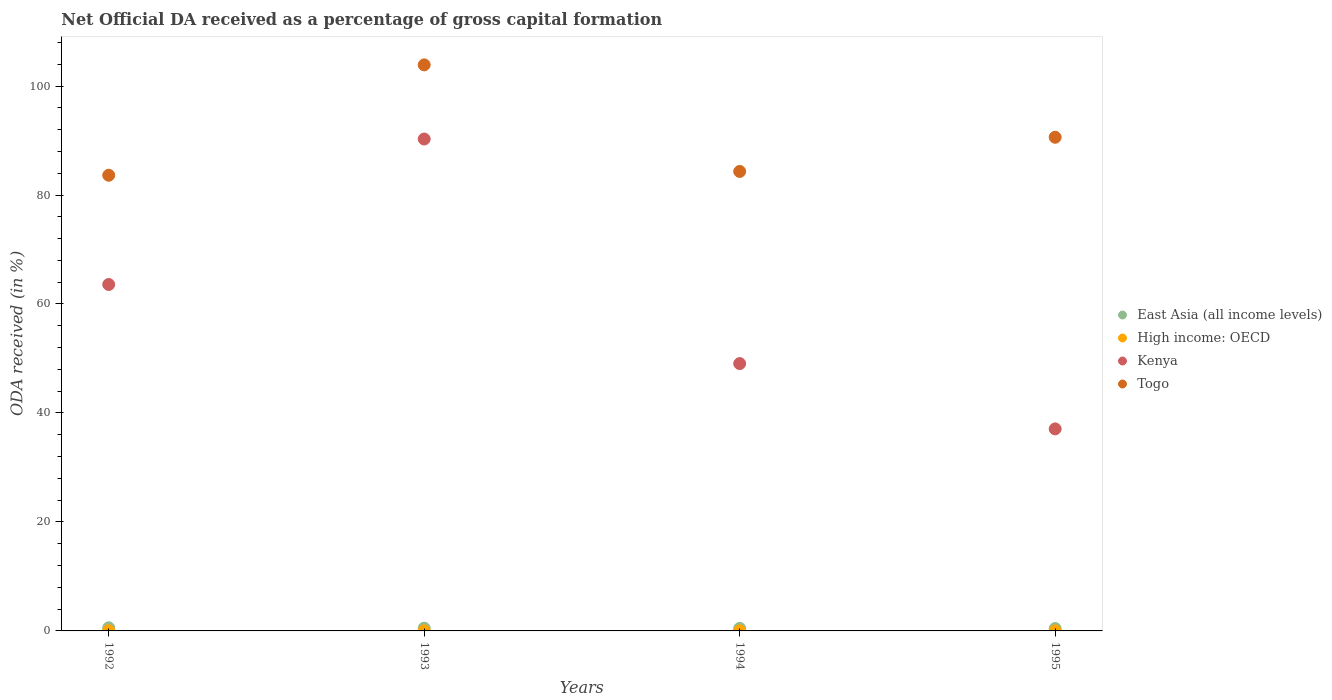How many different coloured dotlines are there?
Your response must be concise. 4. What is the net ODA received in Togo in 1993?
Ensure brevity in your answer.  103.88. Across all years, what is the maximum net ODA received in Togo?
Ensure brevity in your answer.  103.88. Across all years, what is the minimum net ODA received in Togo?
Provide a short and direct response. 83.62. In which year was the net ODA received in East Asia (all income levels) minimum?
Ensure brevity in your answer.  1995. What is the total net ODA received in East Asia (all income levels) in the graph?
Offer a terse response. 1.99. What is the difference between the net ODA received in Togo in 1992 and that in 1995?
Keep it short and to the point. -6.97. What is the difference between the net ODA received in Togo in 1993 and the net ODA received in East Asia (all income levels) in 1995?
Your answer should be compact. 103.45. What is the average net ODA received in Kenya per year?
Your answer should be compact. 60. In the year 1992, what is the difference between the net ODA received in Togo and net ODA received in High income: OECD?
Your answer should be very brief. 83.58. In how many years, is the net ODA received in Togo greater than 56 %?
Provide a short and direct response. 4. What is the ratio of the net ODA received in Kenya in 1992 to that in 1995?
Keep it short and to the point. 1.71. Is the net ODA received in Kenya in 1994 less than that in 1995?
Your response must be concise. No. What is the difference between the highest and the second highest net ODA received in High income: OECD?
Give a very brief answer. 0.02. What is the difference between the highest and the lowest net ODA received in East Asia (all income levels)?
Offer a terse response. 0.15. In how many years, is the net ODA received in Kenya greater than the average net ODA received in Kenya taken over all years?
Make the answer very short. 2. Does the net ODA received in Kenya monotonically increase over the years?
Offer a very short reply. No. Is the net ODA received in Togo strictly greater than the net ODA received in East Asia (all income levels) over the years?
Offer a very short reply. Yes. Is the net ODA received in East Asia (all income levels) strictly less than the net ODA received in Kenya over the years?
Ensure brevity in your answer.  Yes. How many dotlines are there?
Give a very brief answer. 4. Does the graph contain any zero values?
Give a very brief answer. No. How many legend labels are there?
Keep it short and to the point. 4. What is the title of the graph?
Make the answer very short. Net Official DA received as a percentage of gross capital formation. What is the label or title of the Y-axis?
Offer a very short reply. ODA received (in %). What is the ODA received (in %) of East Asia (all income levels) in 1992?
Offer a very short reply. 0.58. What is the ODA received (in %) of High income: OECD in 1992?
Your answer should be very brief. 0.05. What is the ODA received (in %) of Kenya in 1992?
Give a very brief answer. 63.58. What is the ODA received (in %) of Togo in 1992?
Provide a succinct answer. 83.62. What is the ODA received (in %) in East Asia (all income levels) in 1993?
Offer a very short reply. 0.5. What is the ODA received (in %) of High income: OECD in 1993?
Your answer should be very brief. 0.03. What is the ODA received (in %) in Kenya in 1993?
Your answer should be very brief. 90.27. What is the ODA received (in %) in Togo in 1993?
Keep it short and to the point. 103.88. What is the ODA received (in %) in East Asia (all income levels) in 1994?
Give a very brief answer. 0.47. What is the ODA received (in %) of High income: OECD in 1994?
Your response must be concise. 0.03. What is the ODA received (in %) in Kenya in 1994?
Offer a very short reply. 49.06. What is the ODA received (in %) in Togo in 1994?
Your response must be concise. 84.32. What is the ODA received (in %) of East Asia (all income levels) in 1995?
Your answer should be compact. 0.43. What is the ODA received (in %) in High income: OECD in 1995?
Make the answer very short. 0.01. What is the ODA received (in %) in Kenya in 1995?
Offer a terse response. 37.08. What is the ODA received (in %) of Togo in 1995?
Make the answer very short. 90.6. Across all years, what is the maximum ODA received (in %) of East Asia (all income levels)?
Keep it short and to the point. 0.58. Across all years, what is the maximum ODA received (in %) of High income: OECD?
Your response must be concise. 0.05. Across all years, what is the maximum ODA received (in %) in Kenya?
Offer a terse response. 90.27. Across all years, what is the maximum ODA received (in %) in Togo?
Keep it short and to the point. 103.88. Across all years, what is the minimum ODA received (in %) in East Asia (all income levels)?
Offer a very short reply. 0.43. Across all years, what is the minimum ODA received (in %) of High income: OECD?
Ensure brevity in your answer.  0.01. Across all years, what is the minimum ODA received (in %) in Kenya?
Your answer should be very brief. 37.08. Across all years, what is the minimum ODA received (in %) of Togo?
Give a very brief answer. 83.62. What is the total ODA received (in %) of East Asia (all income levels) in the graph?
Offer a terse response. 1.99. What is the total ODA received (in %) of High income: OECD in the graph?
Your response must be concise. 0.11. What is the total ODA received (in %) of Kenya in the graph?
Your response must be concise. 239.99. What is the total ODA received (in %) in Togo in the graph?
Make the answer very short. 362.43. What is the difference between the ODA received (in %) of East Asia (all income levels) in 1992 and that in 1993?
Provide a succinct answer. 0.08. What is the difference between the ODA received (in %) of High income: OECD in 1992 and that in 1993?
Your response must be concise. 0.02. What is the difference between the ODA received (in %) of Kenya in 1992 and that in 1993?
Ensure brevity in your answer.  -26.69. What is the difference between the ODA received (in %) of Togo in 1992 and that in 1993?
Keep it short and to the point. -20.26. What is the difference between the ODA received (in %) of East Asia (all income levels) in 1992 and that in 1994?
Offer a terse response. 0.11. What is the difference between the ODA received (in %) in High income: OECD in 1992 and that in 1994?
Your response must be concise. 0.02. What is the difference between the ODA received (in %) in Kenya in 1992 and that in 1994?
Provide a short and direct response. 14.52. What is the difference between the ODA received (in %) in Togo in 1992 and that in 1994?
Ensure brevity in your answer.  -0.7. What is the difference between the ODA received (in %) in East Asia (all income levels) in 1992 and that in 1995?
Give a very brief answer. 0.15. What is the difference between the ODA received (in %) of High income: OECD in 1992 and that in 1995?
Your response must be concise. 0.04. What is the difference between the ODA received (in %) in Kenya in 1992 and that in 1995?
Keep it short and to the point. 26.5. What is the difference between the ODA received (in %) of Togo in 1992 and that in 1995?
Your answer should be compact. -6.97. What is the difference between the ODA received (in %) in East Asia (all income levels) in 1993 and that in 1994?
Your answer should be compact. 0.04. What is the difference between the ODA received (in %) of High income: OECD in 1993 and that in 1994?
Keep it short and to the point. 0. What is the difference between the ODA received (in %) in Kenya in 1993 and that in 1994?
Make the answer very short. 41.21. What is the difference between the ODA received (in %) of Togo in 1993 and that in 1994?
Keep it short and to the point. 19.56. What is the difference between the ODA received (in %) in East Asia (all income levels) in 1993 and that in 1995?
Ensure brevity in your answer.  0.07. What is the difference between the ODA received (in %) in High income: OECD in 1993 and that in 1995?
Your response must be concise. 0.02. What is the difference between the ODA received (in %) in Kenya in 1993 and that in 1995?
Keep it short and to the point. 53.2. What is the difference between the ODA received (in %) in Togo in 1993 and that in 1995?
Offer a terse response. 13.28. What is the difference between the ODA received (in %) of East Asia (all income levels) in 1994 and that in 1995?
Ensure brevity in your answer.  0.03. What is the difference between the ODA received (in %) in High income: OECD in 1994 and that in 1995?
Offer a terse response. 0.01. What is the difference between the ODA received (in %) in Kenya in 1994 and that in 1995?
Keep it short and to the point. 11.99. What is the difference between the ODA received (in %) in Togo in 1994 and that in 1995?
Your answer should be very brief. -6.27. What is the difference between the ODA received (in %) of East Asia (all income levels) in 1992 and the ODA received (in %) of High income: OECD in 1993?
Provide a succinct answer. 0.55. What is the difference between the ODA received (in %) in East Asia (all income levels) in 1992 and the ODA received (in %) in Kenya in 1993?
Your response must be concise. -89.69. What is the difference between the ODA received (in %) of East Asia (all income levels) in 1992 and the ODA received (in %) of Togo in 1993?
Give a very brief answer. -103.3. What is the difference between the ODA received (in %) of High income: OECD in 1992 and the ODA received (in %) of Kenya in 1993?
Make the answer very short. -90.23. What is the difference between the ODA received (in %) of High income: OECD in 1992 and the ODA received (in %) of Togo in 1993?
Make the answer very short. -103.84. What is the difference between the ODA received (in %) in Kenya in 1992 and the ODA received (in %) in Togo in 1993?
Keep it short and to the point. -40.3. What is the difference between the ODA received (in %) in East Asia (all income levels) in 1992 and the ODA received (in %) in High income: OECD in 1994?
Your answer should be very brief. 0.55. What is the difference between the ODA received (in %) in East Asia (all income levels) in 1992 and the ODA received (in %) in Kenya in 1994?
Give a very brief answer. -48.48. What is the difference between the ODA received (in %) of East Asia (all income levels) in 1992 and the ODA received (in %) of Togo in 1994?
Provide a short and direct response. -83.74. What is the difference between the ODA received (in %) of High income: OECD in 1992 and the ODA received (in %) of Kenya in 1994?
Give a very brief answer. -49.02. What is the difference between the ODA received (in %) in High income: OECD in 1992 and the ODA received (in %) in Togo in 1994?
Offer a terse response. -84.28. What is the difference between the ODA received (in %) of Kenya in 1992 and the ODA received (in %) of Togo in 1994?
Give a very brief answer. -20.75. What is the difference between the ODA received (in %) of East Asia (all income levels) in 1992 and the ODA received (in %) of High income: OECD in 1995?
Your answer should be very brief. 0.57. What is the difference between the ODA received (in %) in East Asia (all income levels) in 1992 and the ODA received (in %) in Kenya in 1995?
Keep it short and to the point. -36.5. What is the difference between the ODA received (in %) in East Asia (all income levels) in 1992 and the ODA received (in %) in Togo in 1995?
Your answer should be very brief. -90.02. What is the difference between the ODA received (in %) in High income: OECD in 1992 and the ODA received (in %) in Kenya in 1995?
Provide a short and direct response. -37.03. What is the difference between the ODA received (in %) of High income: OECD in 1992 and the ODA received (in %) of Togo in 1995?
Your response must be concise. -90.55. What is the difference between the ODA received (in %) of Kenya in 1992 and the ODA received (in %) of Togo in 1995?
Your answer should be very brief. -27.02. What is the difference between the ODA received (in %) in East Asia (all income levels) in 1993 and the ODA received (in %) in High income: OECD in 1994?
Your answer should be very brief. 0.48. What is the difference between the ODA received (in %) in East Asia (all income levels) in 1993 and the ODA received (in %) in Kenya in 1994?
Offer a very short reply. -48.56. What is the difference between the ODA received (in %) in East Asia (all income levels) in 1993 and the ODA received (in %) in Togo in 1994?
Give a very brief answer. -83.82. What is the difference between the ODA received (in %) in High income: OECD in 1993 and the ODA received (in %) in Kenya in 1994?
Your answer should be very brief. -49.03. What is the difference between the ODA received (in %) in High income: OECD in 1993 and the ODA received (in %) in Togo in 1994?
Provide a succinct answer. -84.3. What is the difference between the ODA received (in %) of Kenya in 1993 and the ODA received (in %) of Togo in 1994?
Give a very brief answer. 5.95. What is the difference between the ODA received (in %) of East Asia (all income levels) in 1993 and the ODA received (in %) of High income: OECD in 1995?
Your answer should be compact. 0.49. What is the difference between the ODA received (in %) in East Asia (all income levels) in 1993 and the ODA received (in %) in Kenya in 1995?
Provide a succinct answer. -36.57. What is the difference between the ODA received (in %) of East Asia (all income levels) in 1993 and the ODA received (in %) of Togo in 1995?
Make the answer very short. -90.09. What is the difference between the ODA received (in %) of High income: OECD in 1993 and the ODA received (in %) of Kenya in 1995?
Your response must be concise. -37.05. What is the difference between the ODA received (in %) of High income: OECD in 1993 and the ODA received (in %) of Togo in 1995?
Provide a succinct answer. -90.57. What is the difference between the ODA received (in %) in Kenya in 1993 and the ODA received (in %) in Togo in 1995?
Your answer should be very brief. -0.32. What is the difference between the ODA received (in %) of East Asia (all income levels) in 1994 and the ODA received (in %) of High income: OECD in 1995?
Give a very brief answer. 0.46. What is the difference between the ODA received (in %) in East Asia (all income levels) in 1994 and the ODA received (in %) in Kenya in 1995?
Your answer should be compact. -36.61. What is the difference between the ODA received (in %) of East Asia (all income levels) in 1994 and the ODA received (in %) of Togo in 1995?
Give a very brief answer. -90.13. What is the difference between the ODA received (in %) in High income: OECD in 1994 and the ODA received (in %) in Kenya in 1995?
Your answer should be compact. -37.05. What is the difference between the ODA received (in %) in High income: OECD in 1994 and the ODA received (in %) in Togo in 1995?
Provide a succinct answer. -90.57. What is the difference between the ODA received (in %) of Kenya in 1994 and the ODA received (in %) of Togo in 1995?
Your answer should be compact. -41.53. What is the average ODA received (in %) of East Asia (all income levels) per year?
Keep it short and to the point. 0.5. What is the average ODA received (in %) in High income: OECD per year?
Your response must be concise. 0.03. What is the average ODA received (in %) of Kenya per year?
Provide a succinct answer. 60. What is the average ODA received (in %) of Togo per year?
Offer a very short reply. 90.61. In the year 1992, what is the difference between the ODA received (in %) of East Asia (all income levels) and ODA received (in %) of High income: OECD?
Ensure brevity in your answer.  0.53. In the year 1992, what is the difference between the ODA received (in %) in East Asia (all income levels) and ODA received (in %) in Kenya?
Provide a succinct answer. -63. In the year 1992, what is the difference between the ODA received (in %) in East Asia (all income levels) and ODA received (in %) in Togo?
Provide a short and direct response. -83.04. In the year 1992, what is the difference between the ODA received (in %) in High income: OECD and ODA received (in %) in Kenya?
Your answer should be compact. -63.53. In the year 1992, what is the difference between the ODA received (in %) in High income: OECD and ODA received (in %) in Togo?
Your answer should be compact. -83.58. In the year 1992, what is the difference between the ODA received (in %) in Kenya and ODA received (in %) in Togo?
Keep it short and to the point. -20.05. In the year 1993, what is the difference between the ODA received (in %) in East Asia (all income levels) and ODA received (in %) in High income: OECD?
Your response must be concise. 0.47. In the year 1993, what is the difference between the ODA received (in %) of East Asia (all income levels) and ODA received (in %) of Kenya?
Provide a short and direct response. -89.77. In the year 1993, what is the difference between the ODA received (in %) in East Asia (all income levels) and ODA received (in %) in Togo?
Make the answer very short. -103.38. In the year 1993, what is the difference between the ODA received (in %) of High income: OECD and ODA received (in %) of Kenya?
Your response must be concise. -90.24. In the year 1993, what is the difference between the ODA received (in %) of High income: OECD and ODA received (in %) of Togo?
Keep it short and to the point. -103.85. In the year 1993, what is the difference between the ODA received (in %) of Kenya and ODA received (in %) of Togo?
Give a very brief answer. -13.61. In the year 1994, what is the difference between the ODA received (in %) of East Asia (all income levels) and ODA received (in %) of High income: OECD?
Provide a short and direct response. 0.44. In the year 1994, what is the difference between the ODA received (in %) of East Asia (all income levels) and ODA received (in %) of Kenya?
Give a very brief answer. -48.6. In the year 1994, what is the difference between the ODA received (in %) of East Asia (all income levels) and ODA received (in %) of Togo?
Ensure brevity in your answer.  -83.86. In the year 1994, what is the difference between the ODA received (in %) in High income: OECD and ODA received (in %) in Kenya?
Your answer should be very brief. -49.04. In the year 1994, what is the difference between the ODA received (in %) of High income: OECD and ODA received (in %) of Togo?
Offer a terse response. -84.3. In the year 1994, what is the difference between the ODA received (in %) in Kenya and ODA received (in %) in Togo?
Your answer should be compact. -35.26. In the year 1995, what is the difference between the ODA received (in %) of East Asia (all income levels) and ODA received (in %) of High income: OECD?
Your response must be concise. 0.42. In the year 1995, what is the difference between the ODA received (in %) of East Asia (all income levels) and ODA received (in %) of Kenya?
Make the answer very short. -36.64. In the year 1995, what is the difference between the ODA received (in %) of East Asia (all income levels) and ODA received (in %) of Togo?
Provide a short and direct response. -90.16. In the year 1995, what is the difference between the ODA received (in %) in High income: OECD and ODA received (in %) in Kenya?
Offer a very short reply. -37.07. In the year 1995, what is the difference between the ODA received (in %) of High income: OECD and ODA received (in %) of Togo?
Keep it short and to the point. -90.59. In the year 1995, what is the difference between the ODA received (in %) of Kenya and ODA received (in %) of Togo?
Provide a succinct answer. -53.52. What is the ratio of the ODA received (in %) of East Asia (all income levels) in 1992 to that in 1993?
Make the answer very short. 1.15. What is the ratio of the ODA received (in %) in High income: OECD in 1992 to that in 1993?
Your answer should be very brief. 1.53. What is the ratio of the ODA received (in %) in Kenya in 1992 to that in 1993?
Keep it short and to the point. 0.7. What is the ratio of the ODA received (in %) of Togo in 1992 to that in 1993?
Your answer should be very brief. 0.81. What is the ratio of the ODA received (in %) in East Asia (all income levels) in 1992 to that in 1994?
Give a very brief answer. 1.24. What is the ratio of the ODA received (in %) of High income: OECD in 1992 to that in 1994?
Keep it short and to the point. 1.8. What is the ratio of the ODA received (in %) in Kenya in 1992 to that in 1994?
Give a very brief answer. 1.3. What is the ratio of the ODA received (in %) of East Asia (all income levels) in 1992 to that in 1995?
Make the answer very short. 1.33. What is the ratio of the ODA received (in %) in High income: OECD in 1992 to that in 1995?
Provide a succinct answer. 4.37. What is the ratio of the ODA received (in %) in Kenya in 1992 to that in 1995?
Keep it short and to the point. 1.71. What is the ratio of the ODA received (in %) in Togo in 1992 to that in 1995?
Your answer should be compact. 0.92. What is the ratio of the ODA received (in %) in East Asia (all income levels) in 1993 to that in 1994?
Give a very brief answer. 1.08. What is the ratio of the ODA received (in %) in High income: OECD in 1993 to that in 1994?
Ensure brevity in your answer.  1.18. What is the ratio of the ODA received (in %) of Kenya in 1993 to that in 1994?
Give a very brief answer. 1.84. What is the ratio of the ODA received (in %) of Togo in 1993 to that in 1994?
Your answer should be very brief. 1.23. What is the ratio of the ODA received (in %) of East Asia (all income levels) in 1993 to that in 1995?
Make the answer very short. 1.16. What is the ratio of the ODA received (in %) of High income: OECD in 1993 to that in 1995?
Make the answer very short. 2.86. What is the ratio of the ODA received (in %) in Kenya in 1993 to that in 1995?
Make the answer very short. 2.43. What is the ratio of the ODA received (in %) of Togo in 1993 to that in 1995?
Your response must be concise. 1.15. What is the ratio of the ODA received (in %) in East Asia (all income levels) in 1994 to that in 1995?
Your answer should be compact. 1.07. What is the ratio of the ODA received (in %) in High income: OECD in 1994 to that in 1995?
Your answer should be compact. 2.43. What is the ratio of the ODA received (in %) in Kenya in 1994 to that in 1995?
Offer a very short reply. 1.32. What is the ratio of the ODA received (in %) in Togo in 1994 to that in 1995?
Make the answer very short. 0.93. What is the difference between the highest and the second highest ODA received (in %) in East Asia (all income levels)?
Offer a terse response. 0.08. What is the difference between the highest and the second highest ODA received (in %) of High income: OECD?
Offer a very short reply. 0.02. What is the difference between the highest and the second highest ODA received (in %) in Kenya?
Your answer should be compact. 26.69. What is the difference between the highest and the second highest ODA received (in %) in Togo?
Provide a short and direct response. 13.28. What is the difference between the highest and the lowest ODA received (in %) in East Asia (all income levels)?
Your answer should be compact. 0.15. What is the difference between the highest and the lowest ODA received (in %) in High income: OECD?
Give a very brief answer. 0.04. What is the difference between the highest and the lowest ODA received (in %) of Kenya?
Offer a very short reply. 53.2. What is the difference between the highest and the lowest ODA received (in %) in Togo?
Provide a short and direct response. 20.26. 